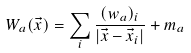Convert formula to latex. <formula><loc_0><loc_0><loc_500><loc_500>W _ { a } ( \vec { x } ) = \sum _ { i } \frac { ( w _ { a } ) _ { i } } { | \vec { x } - \vec { x } _ { i } | } + m _ { a }</formula> 